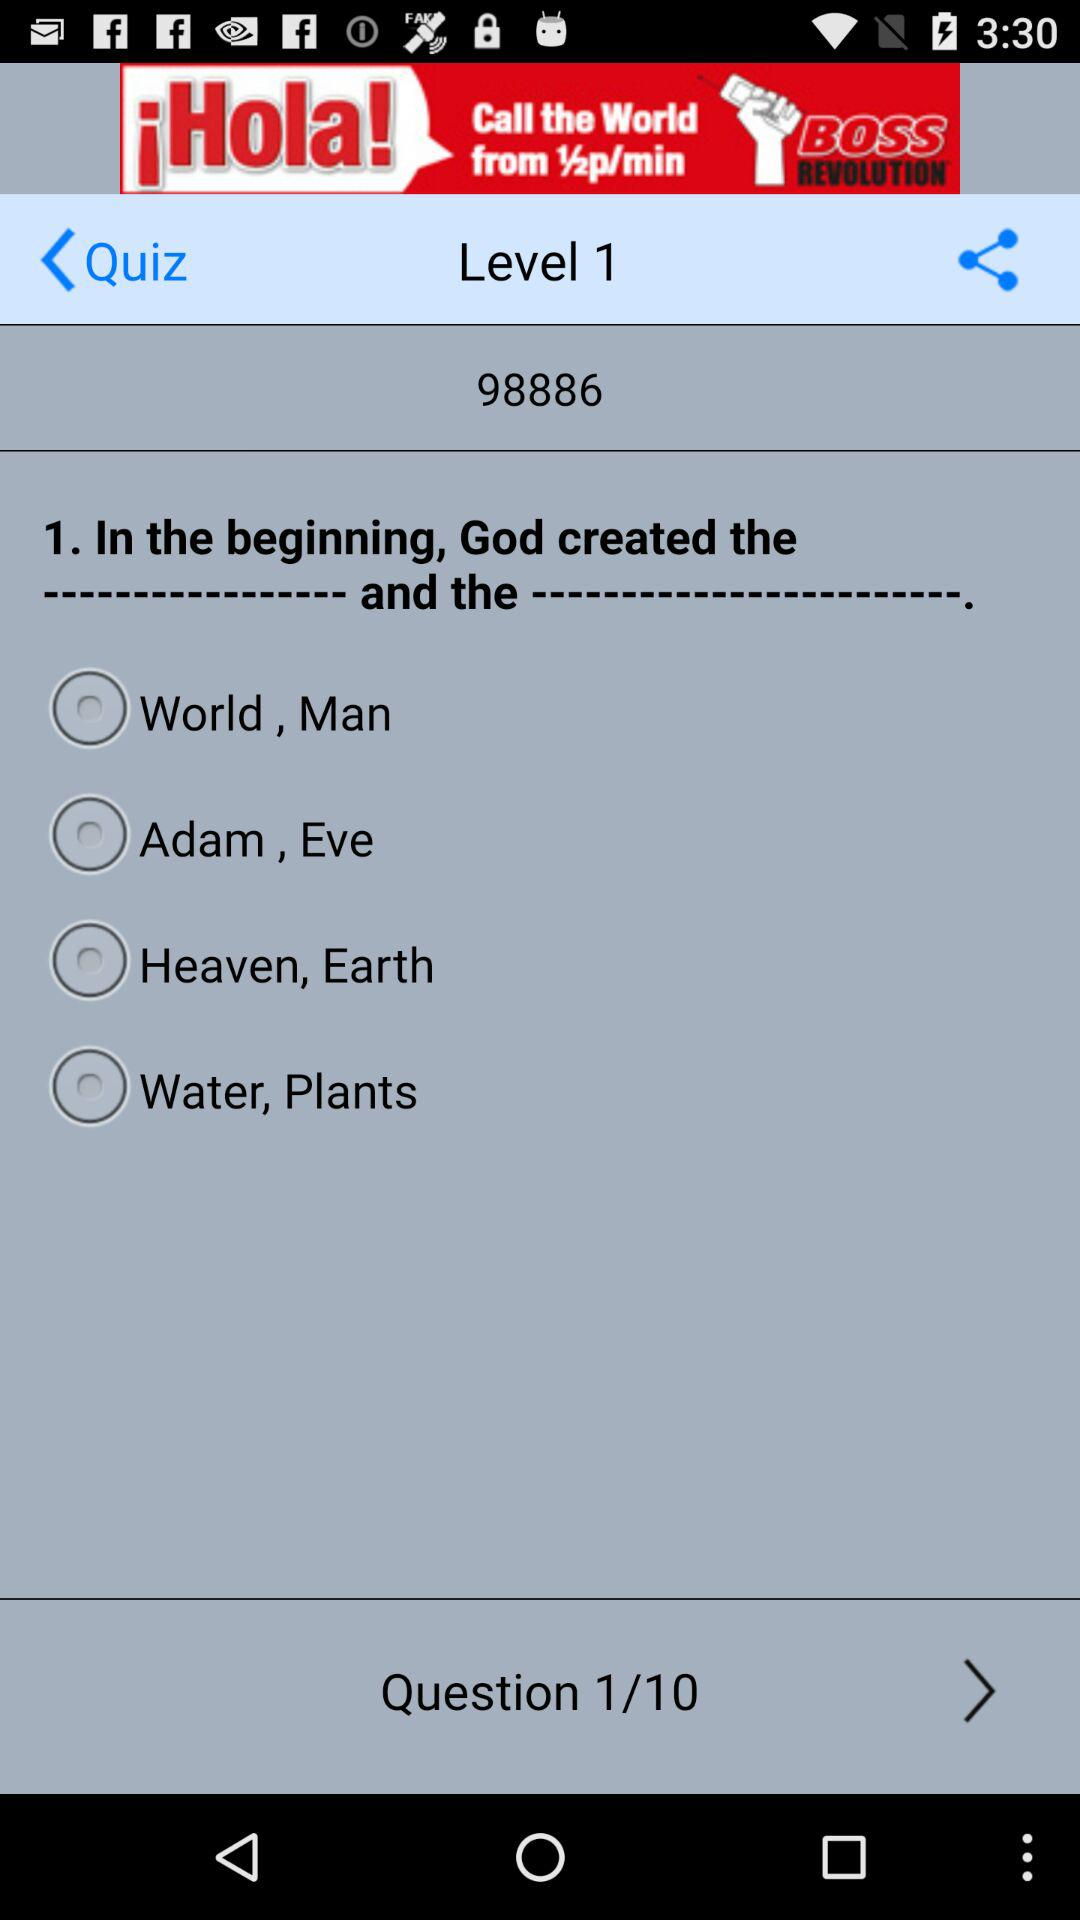What is the quiz number? The quiz number is 98886. 